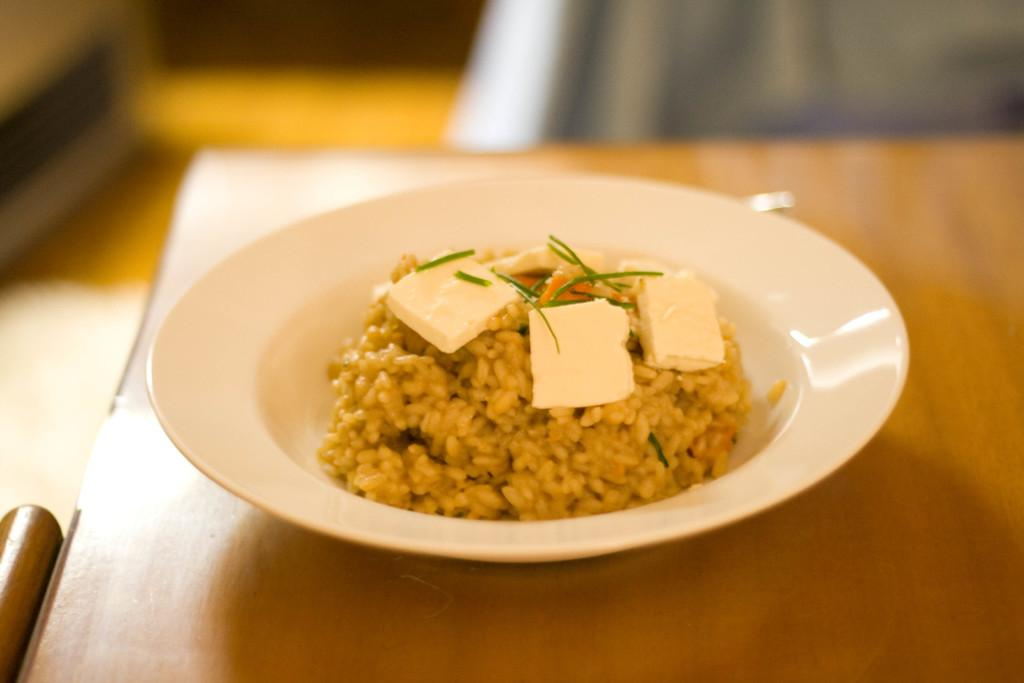What is on the table in the image? There is a plate on the table in the image. What is on the plate? The plate contains rice and cheese, along with other objects. Is there any seating visible in the image? Yes, there is a chair beside the table. What can be seen at the top of the image? There is a cloth visible at the top of the image. How much does the kettle cost in the image? There is no kettle present in the image, so the cost cannot be determined. 